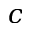<formula> <loc_0><loc_0><loc_500><loc_500>c</formula> 